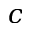<formula> <loc_0><loc_0><loc_500><loc_500>c</formula> 